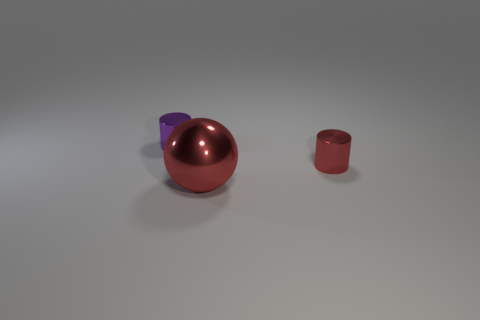Add 1 spheres. How many objects exist? 4 Subtract all cylinders. How many objects are left? 1 Add 1 metallic balls. How many metallic balls exist? 2 Subtract 0 brown cubes. How many objects are left? 3 Subtract all large brown rubber balls. Subtract all small things. How many objects are left? 1 Add 2 red shiny objects. How many red shiny objects are left? 4 